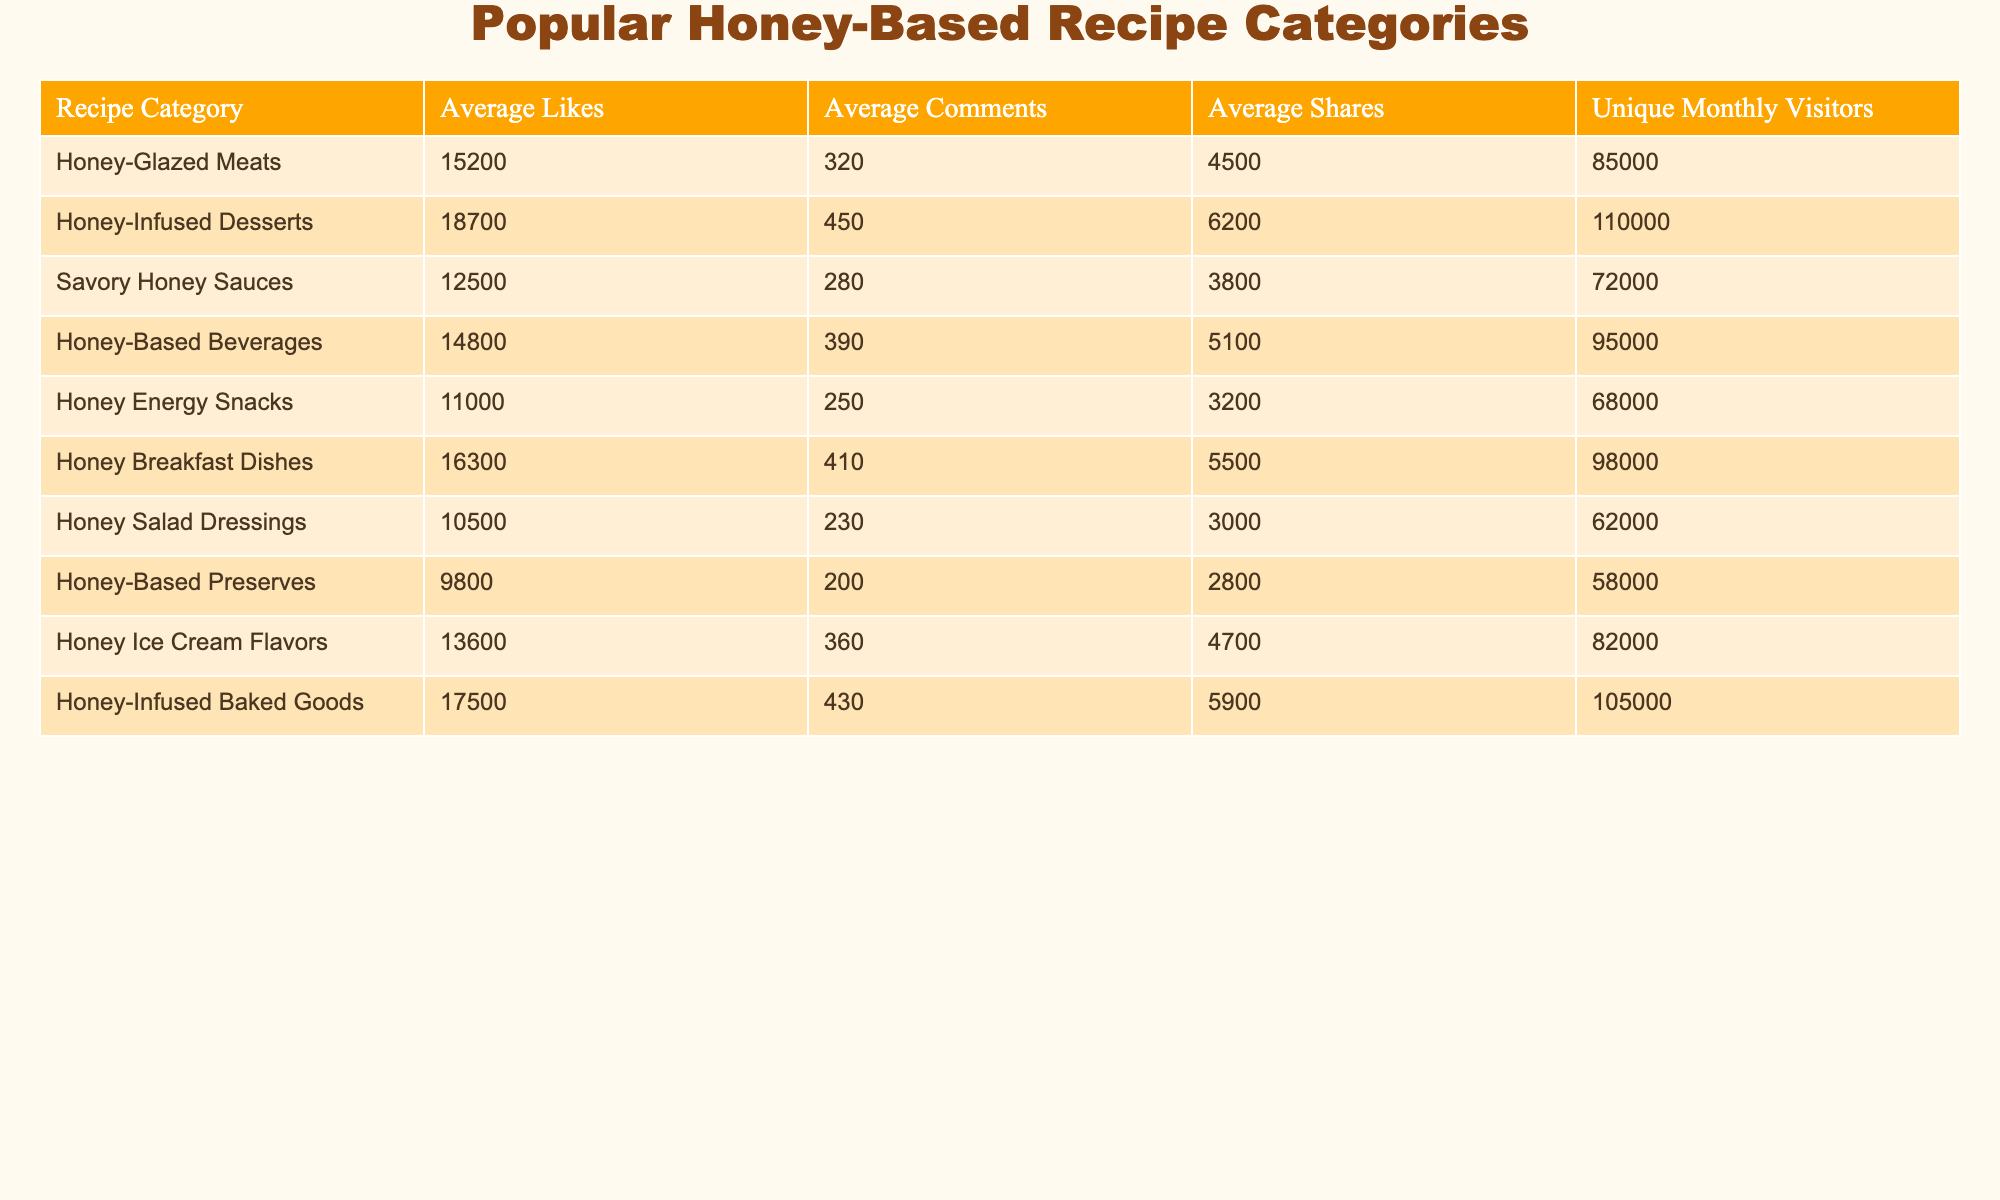What is the average number of likes for Honey-Based Beverages? The average number of likes for Honey-Based Beverages can be directly found in the table. It shows 14,800 average likes for this category.
Answer: 14,800 Which recipe category has the highest number of unique monthly visitors? By examining the Unique Monthly Visitors column, Honey-Infused Desserts has the highest value of 110,000.
Answer: 110,000 How many more shares does Honey-Infused Desserts have than Honey Energy Snacks? To find this, subtract the average shares of Honey Energy Snacks (3,200) from that of Honey-Infused Desserts (6,200). This gives us 6,200 - 3,200 = 3,000 more shares.
Answer: 3,000 Is the average number of comments for Honey Ice Cream Flavors greater than 400? The table shows that Honey Ice Cream Flavors has 360 average comments, which is less than 400, making the statement false.
Answer: No What is the total number of shares across all the recipe categories? To find the total shares, sum the average shares for all categories: 4,500 + 6,200 + 3,800 + 5,100 + 3,200 + 5,500 + 3,000 + 2,800 + 4,700 + 5,900 = 40,700.
Answer: 40,700 Which recipe category has the lowest engagement metrics across likes, comments, and shares? To find this, we should look for the recipe category with the least values across all three engagement metrics. Honey-Based Preserves has the lowest average likes (9,800), comments (200), and shares (2,800), confirming this category as the least engaging.
Answer: Honey-Based Preserves How does the average number of comments for Honey-Glazed Meats compare to Honey-Infused Desserts? Honey-Glazed Meats has 320 average comments while Honey-Infused Desserts has 450. Subtracting gives us 450 - 320 = 130 more comments for Honey-Infused Desserts.
Answer: 130 more comments Which recipe category has the lowest average likes? By reviewing the Average Likes column, it’s clear that Honey-Based Preserves has the lowest average likes at 9,800.
Answer: 9,800 